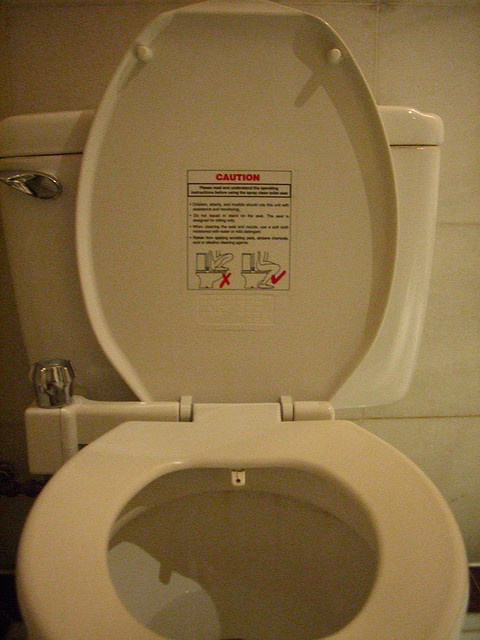Describe the objects in this image and their specific colors. I can see a toilet in tan, maroon, and olive tones in this image. 